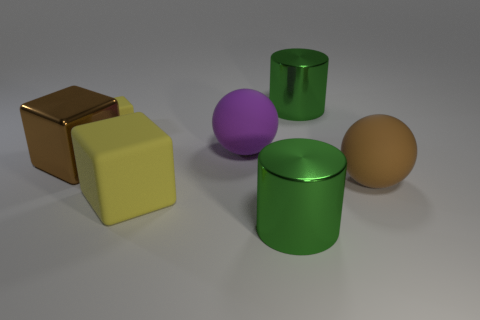Are there more large purple objects than yellow rubber objects?
Your response must be concise. No. There is a yellow cube that is the same size as the brown ball; what material is it?
Your answer should be compact. Rubber. There is a green cylinder that is in front of the brown metal block; is its size the same as the small yellow block?
Offer a very short reply. No. What number of blocks are green metallic things or rubber objects?
Provide a short and direct response. 2. There is a big green object that is in front of the large brown metal cube; what is it made of?
Provide a succinct answer. Metal. Are there fewer large metal cubes than tiny blue cylinders?
Ensure brevity in your answer.  No. There is a matte object that is both in front of the large purple ball and left of the large purple matte ball; how big is it?
Your response must be concise. Large. There is a metallic cylinder behind the large yellow rubber object that is left of the metallic object behind the big shiny cube; how big is it?
Provide a succinct answer. Large. What number of other things are the same color as the tiny block?
Offer a terse response. 1. Do the large object that is behind the small block and the big rubber cube have the same color?
Provide a short and direct response. No. 